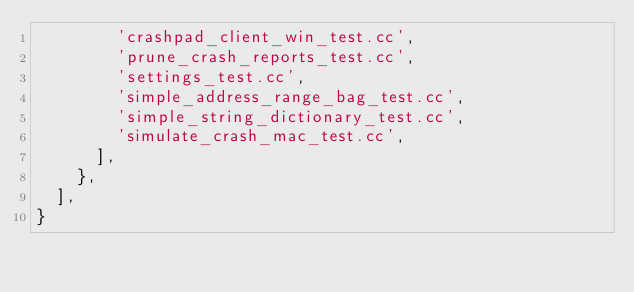Convert code to text. <code><loc_0><loc_0><loc_500><loc_500><_Python_>        'crashpad_client_win_test.cc',
        'prune_crash_reports_test.cc',
        'settings_test.cc',
        'simple_address_range_bag_test.cc',
        'simple_string_dictionary_test.cc',
        'simulate_crash_mac_test.cc',
      ],
    },
  ],
}
</code> 